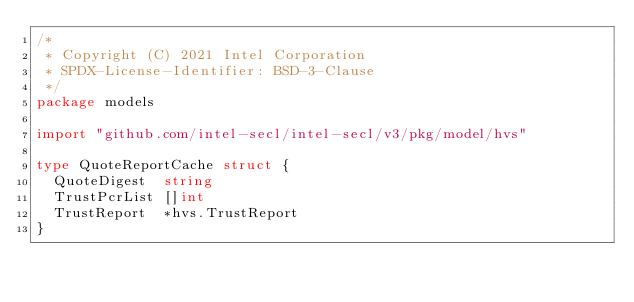Convert code to text. <code><loc_0><loc_0><loc_500><loc_500><_Go_>/*
 * Copyright (C) 2021 Intel Corporation
 * SPDX-License-Identifier: BSD-3-Clause
 */
package models

import "github.com/intel-secl/intel-secl/v3/pkg/model/hvs"

type QuoteReportCache struct {
	QuoteDigest  string
	TrustPcrList []int
	TrustReport  *hvs.TrustReport
}
</code> 